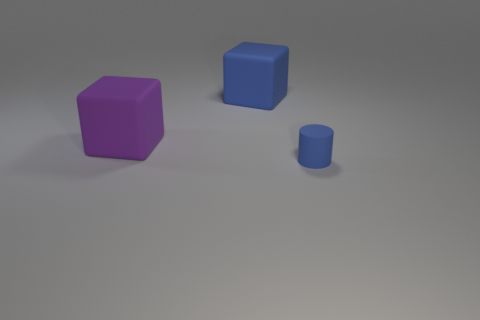Add 2 small purple metal things. How many objects exist? 5 Subtract all blue cubes. How many cubes are left? 1 Subtract all purple objects. Subtract all big purple things. How many objects are left? 1 Add 1 blue rubber cylinders. How many blue rubber cylinders are left? 2 Add 2 big matte objects. How many big matte objects exist? 4 Subtract 0 purple balls. How many objects are left? 3 Subtract all cylinders. How many objects are left? 2 Subtract 1 cubes. How many cubes are left? 1 Subtract all purple cylinders. Subtract all brown spheres. How many cylinders are left? 1 